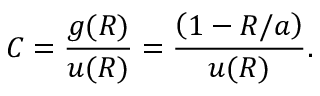<formula> <loc_0><loc_0><loc_500><loc_500>C = \frac { g ( R ) } { u ( R ) } = \frac { \left ( 1 - R / a \right ) } { u ( R ) } .</formula> 